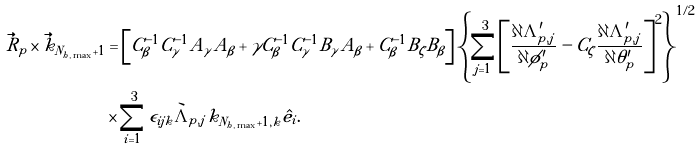<formula> <loc_0><loc_0><loc_500><loc_500>\vec { R } _ { p } \times \vec { k } _ { N _ { h , \max } + 1 } & = \left [ C _ { \beta } ^ { - 1 } C _ { \gamma } ^ { - 1 } A _ { \gamma } A _ { \beta } + \gamma C _ { \beta } ^ { - 1 } C _ { \gamma } ^ { - 1 } B _ { \gamma } A _ { \beta } + C _ { \beta } ^ { - 1 } B _ { \zeta } B _ { \beta } \right ] \left \{ \sum _ { j = 1 } ^ { 3 } \left [ \frac { \partial \Lambda ^ { \prime } _ { p , j } } { \partial \phi ^ { \prime } _ { p } } - C _ { \zeta } \frac { \partial \Lambda ^ { \prime } _ { p , j } } { \partial \theta ^ { \prime } _ { p } } \right ] ^ { 2 } \right \} ^ { 1 / 2 } \\ & \times \sum _ { i = 1 } ^ { 3 } \epsilon _ { i j k } \grave { \Lambda } _ { p , j } k _ { N _ { h , \max } + 1 , k } \hat { e _ { i } } .</formula> 